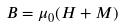<formula> <loc_0><loc_0><loc_500><loc_500>B = \mu _ { 0 } ( H + M )</formula> 